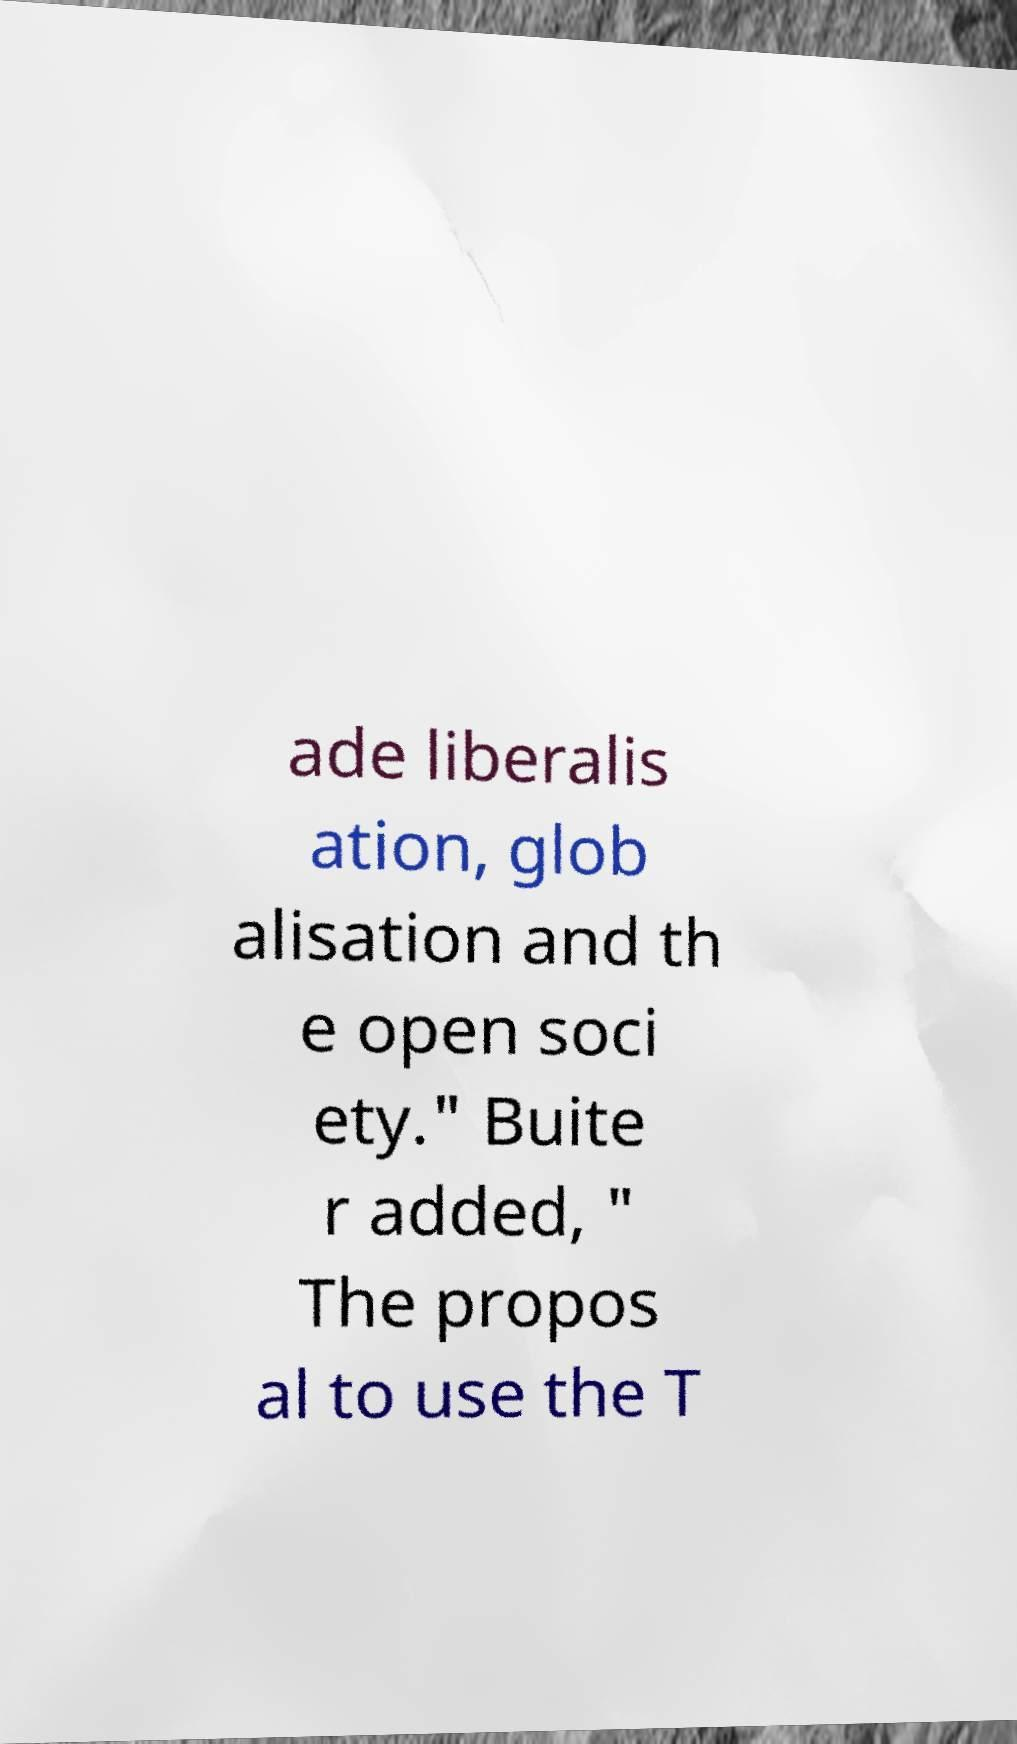Please read and relay the text visible in this image. What does it say? ade liberalis ation, glob alisation and th e open soci ety." Buite r added, " The propos al to use the T 